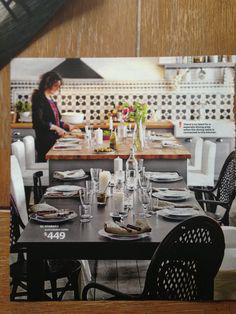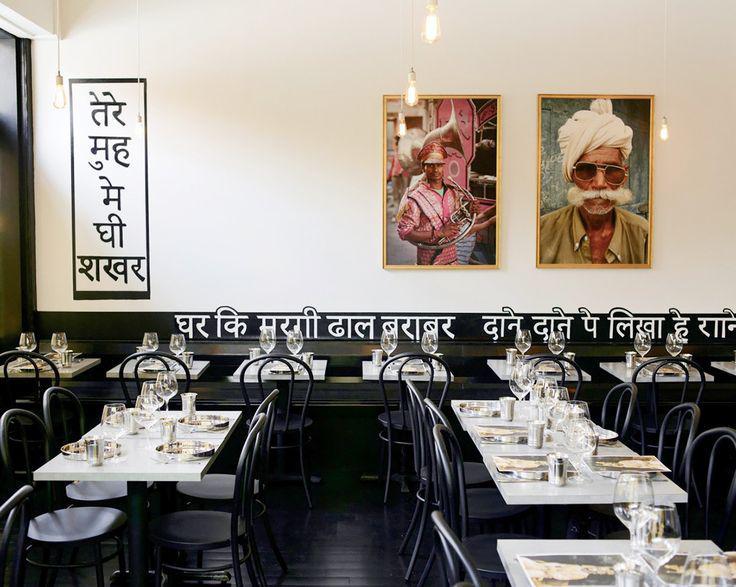The first image is the image on the left, the second image is the image on the right. Evaluate the accuracy of this statement regarding the images: "One of the images features a restaurant with textual wall art.". Is it true? Answer yes or no. Yes. The first image is the image on the left, the second image is the image on the right. Evaluate the accuracy of this statement regarding the images: "There are some lighting fixtures on the rear walls, instead of just on the ceilings.". Is it true? Answer yes or no. No. 